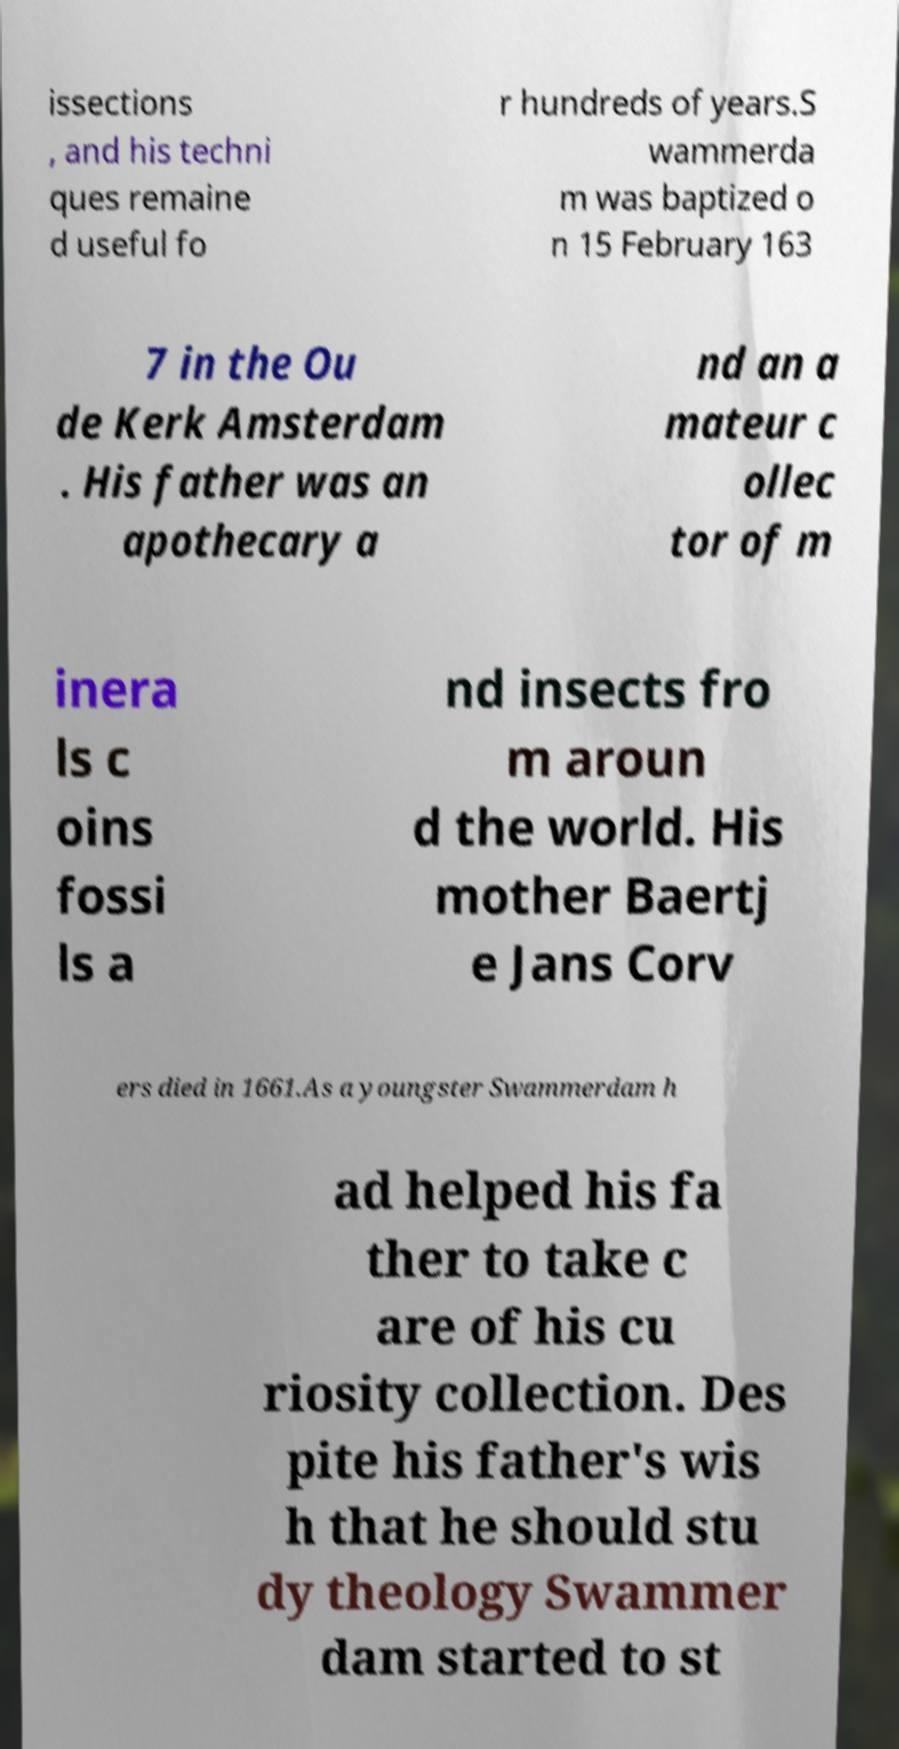There's text embedded in this image that I need extracted. Can you transcribe it verbatim? issections , and his techni ques remaine d useful fo r hundreds of years.S wammerda m was baptized o n 15 February 163 7 in the Ou de Kerk Amsterdam . His father was an apothecary a nd an a mateur c ollec tor of m inera ls c oins fossi ls a nd insects fro m aroun d the world. His mother Baertj e Jans Corv ers died in 1661.As a youngster Swammerdam h ad helped his fa ther to take c are of his cu riosity collection. Des pite his father's wis h that he should stu dy theology Swammer dam started to st 